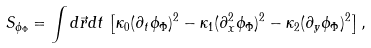<formula> <loc_0><loc_0><loc_500><loc_500>S _ { \phi _ { \Phi } } = \int d \vec { r } d t \, \left [ \kappa _ { 0 } ( \partial _ { t } \phi _ { \Phi } ) ^ { 2 } - \kappa _ { 1 } ( \partial ^ { 2 } _ { x } \phi _ { \Phi } ) ^ { 2 } - \kappa _ { 2 } ( \partial _ { y } \phi _ { \Phi } ) ^ { 2 } \right ] ,</formula> 